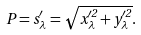<formula> <loc_0><loc_0><loc_500><loc_500>P = s _ { \lambda } ^ { \prime } = \sqrt { x _ { \lambda } ^ { \prime 2 } + y _ { \lambda } ^ { \prime 2 } } .</formula> 